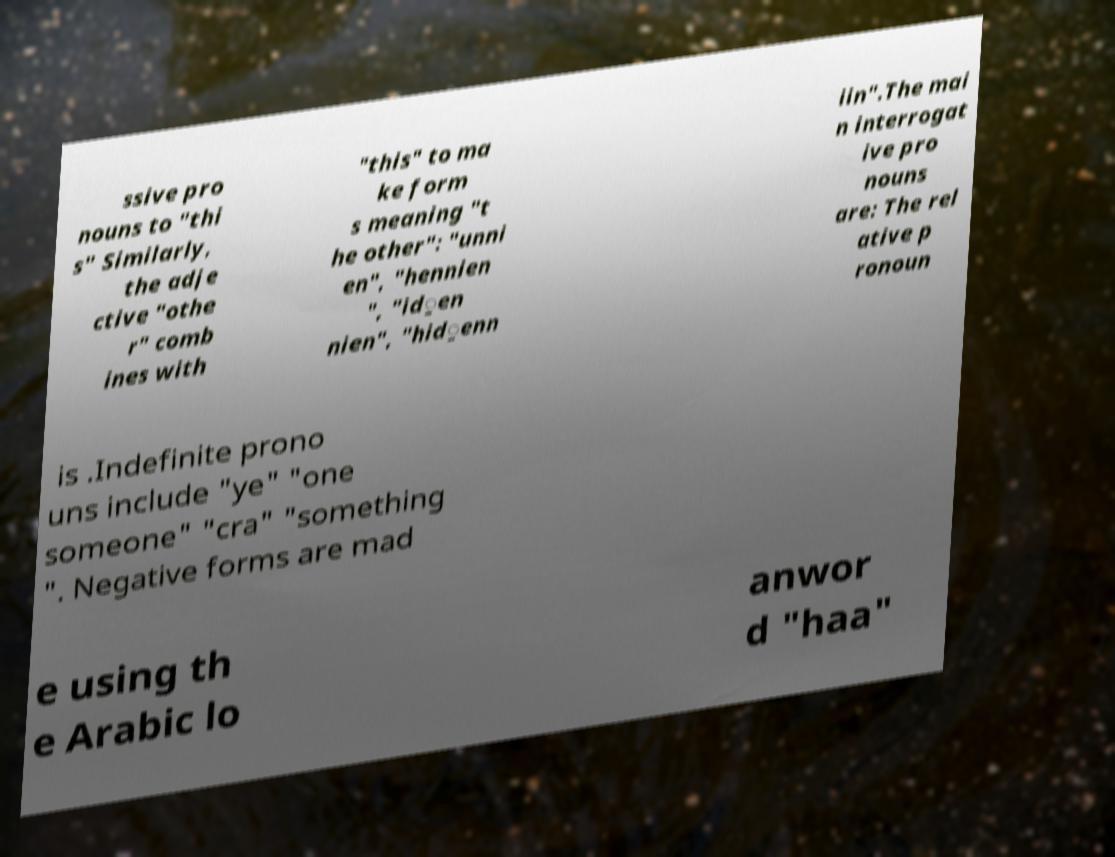Could you extract and type out the text from this image? ssive pro nouns to "thi s" Similarly, the adje ctive "othe r" comb ines with "this" to ma ke form s meaning "t he other": "unni en", "hennien ", "id̠en nien", "hid̠enn iin".The mai n interrogat ive pro nouns are: The rel ative p ronoun is .Indefinite prono uns include "ye" "one someone" "cra" "something ". Negative forms are mad e using th e Arabic lo anwor d "haa" 